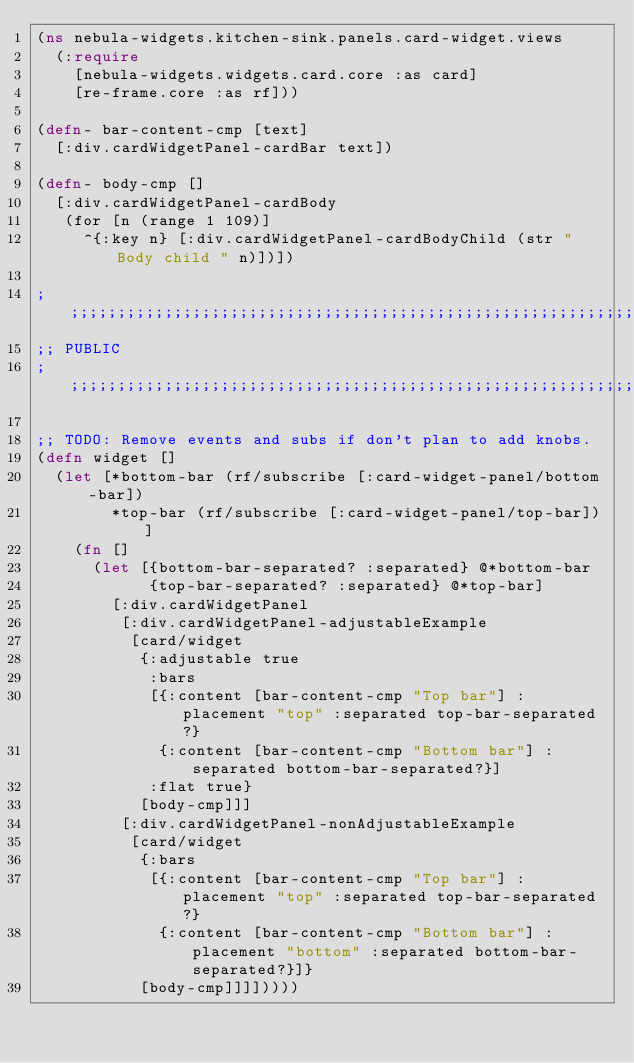Convert code to text. <code><loc_0><loc_0><loc_500><loc_500><_Clojure_>(ns nebula-widgets.kitchen-sink.panels.card-widget.views
  (:require
    [nebula-widgets.widgets.card.core :as card]
    [re-frame.core :as rf]))

(defn- bar-content-cmp [text]
  [:div.cardWidgetPanel-cardBar text])

(defn- body-cmp []
  [:div.cardWidgetPanel-cardBody
   (for [n (range 1 109)]
     ^{:key n} [:div.cardWidgetPanel-cardBodyChild (str "Body child " n)])])

;;;;;;;;;;;;;;;;;;;;;;;;;;;;;;;;;;;;;;;;;;;;;;;;;;;;;;;;;;;;;;;;;;;;;;;;;;;;;;;;
;; PUBLIC
;;;;;;;;;;;;;;;;;;;;;;;;;;;;;;;;;;;;;;;;;;;;;;;;;;;;;;;;;;;;;;;;;;;;;;;;;;;;;;;;

;; TODO: Remove events and subs if don't plan to add knobs.
(defn widget []
  (let [*bottom-bar (rf/subscribe [:card-widget-panel/bottom-bar])
        *top-bar (rf/subscribe [:card-widget-panel/top-bar])]
    (fn []
      (let [{bottom-bar-separated? :separated} @*bottom-bar
            {top-bar-separated? :separated} @*top-bar]
        [:div.cardWidgetPanel
         [:div.cardWidgetPanel-adjustableExample
          [card/widget
           {:adjustable true
            :bars
            [{:content [bar-content-cmp "Top bar"] :placement "top" :separated top-bar-separated?}
             {:content [bar-content-cmp "Bottom bar"] :separated bottom-bar-separated?}]
            :flat true}
           [body-cmp]]]
         [:div.cardWidgetPanel-nonAdjustableExample
          [card/widget
           {:bars
            [{:content [bar-content-cmp "Top bar"] :placement "top" :separated top-bar-separated?}
             {:content [bar-content-cmp "Bottom bar"] :placement "bottom" :separated bottom-bar-separated?}]}
           [body-cmp]]]]))))
</code> 